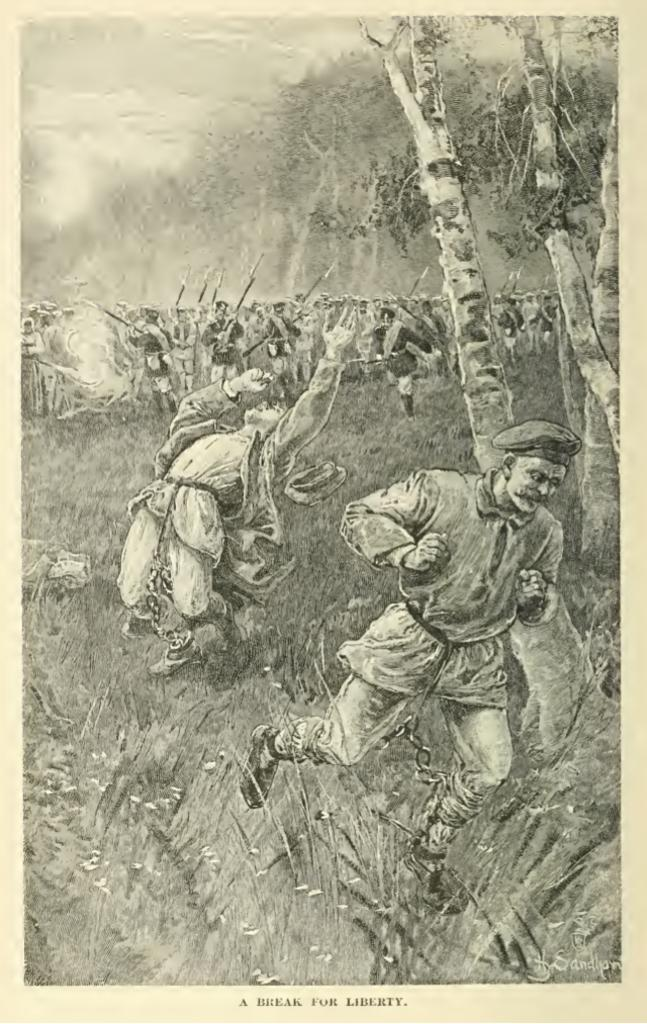<image>
Create a compact narrative representing the image presented. A black and white picture labeled " A break for liberty". 